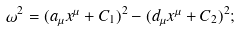Convert formula to latex. <formula><loc_0><loc_0><loc_500><loc_500>\omega ^ { 2 } = ( a _ { \mu } x ^ { \mu } + C _ { 1 } ) ^ { 2 } - ( d _ { \mu } x ^ { \mu } + C _ { 2 } ) ^ { 2 } ;</formula> 